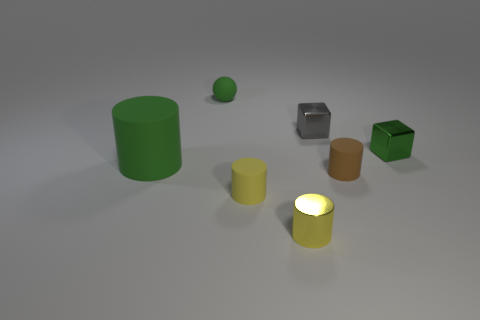Subtract all big cylinders. How many cylinders are left? 3 Add 1 big cylinders. How many objects exist? 8 Subtract all green cylinders. How many cylinders are left? 3 Subtract all cubes. How many objects are left? 5 Subtract 1 cylinders. How many cylinders are left? 3 Subtract all cyan cubes. Subtract all gray spheres. How many cubes are left? 2 Subtract all blue cylinders. How many purple blocks are left? 0 Subtract all tiny matte spheres. Subtract all gray metallic blocks. How many objects are left? 5 Add 4 brown cylinders. How many brown cylinders are left? 5 Add 4 tiny brown matte cylinders. How many tiny brown matte cylinders exist? 5 